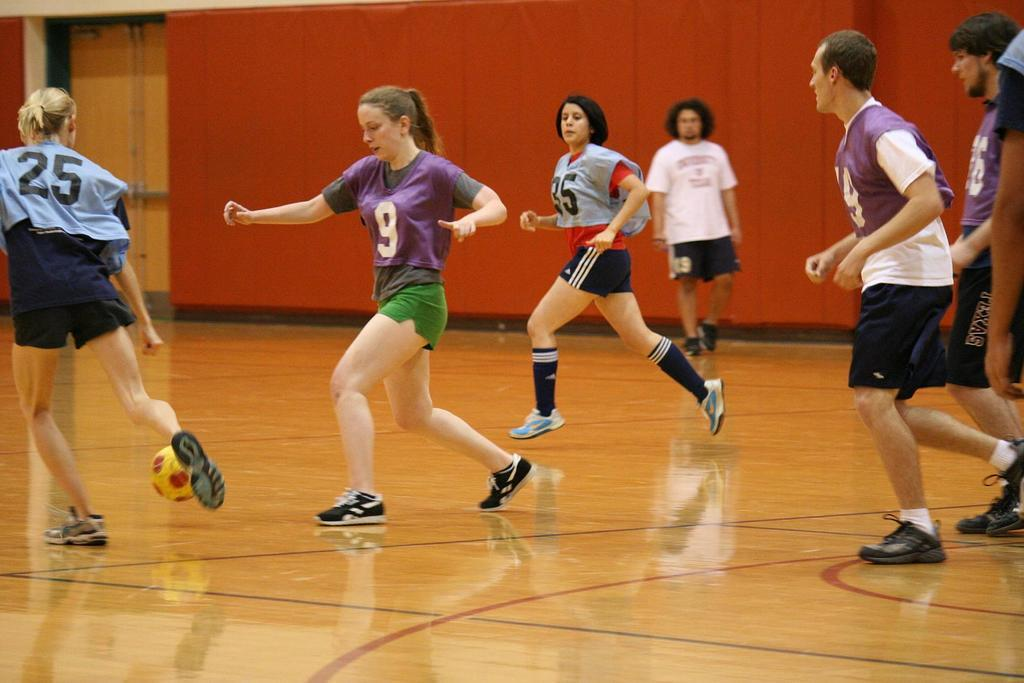What are the people in the image doing? There is a group of people playing a game on the floor. Can you describe the actions of the woman on the left side? A woman is kicking a ball on the left side. What color is the wall visible in the image? There is a red color wall at the top of the image. What is the color of the door in the image? There is a yellow color door in the image. How many minutes does it take for the waste to be disposed of in the image? There is no mention of waste or its disposal in the image, so this question cannot be answered. 